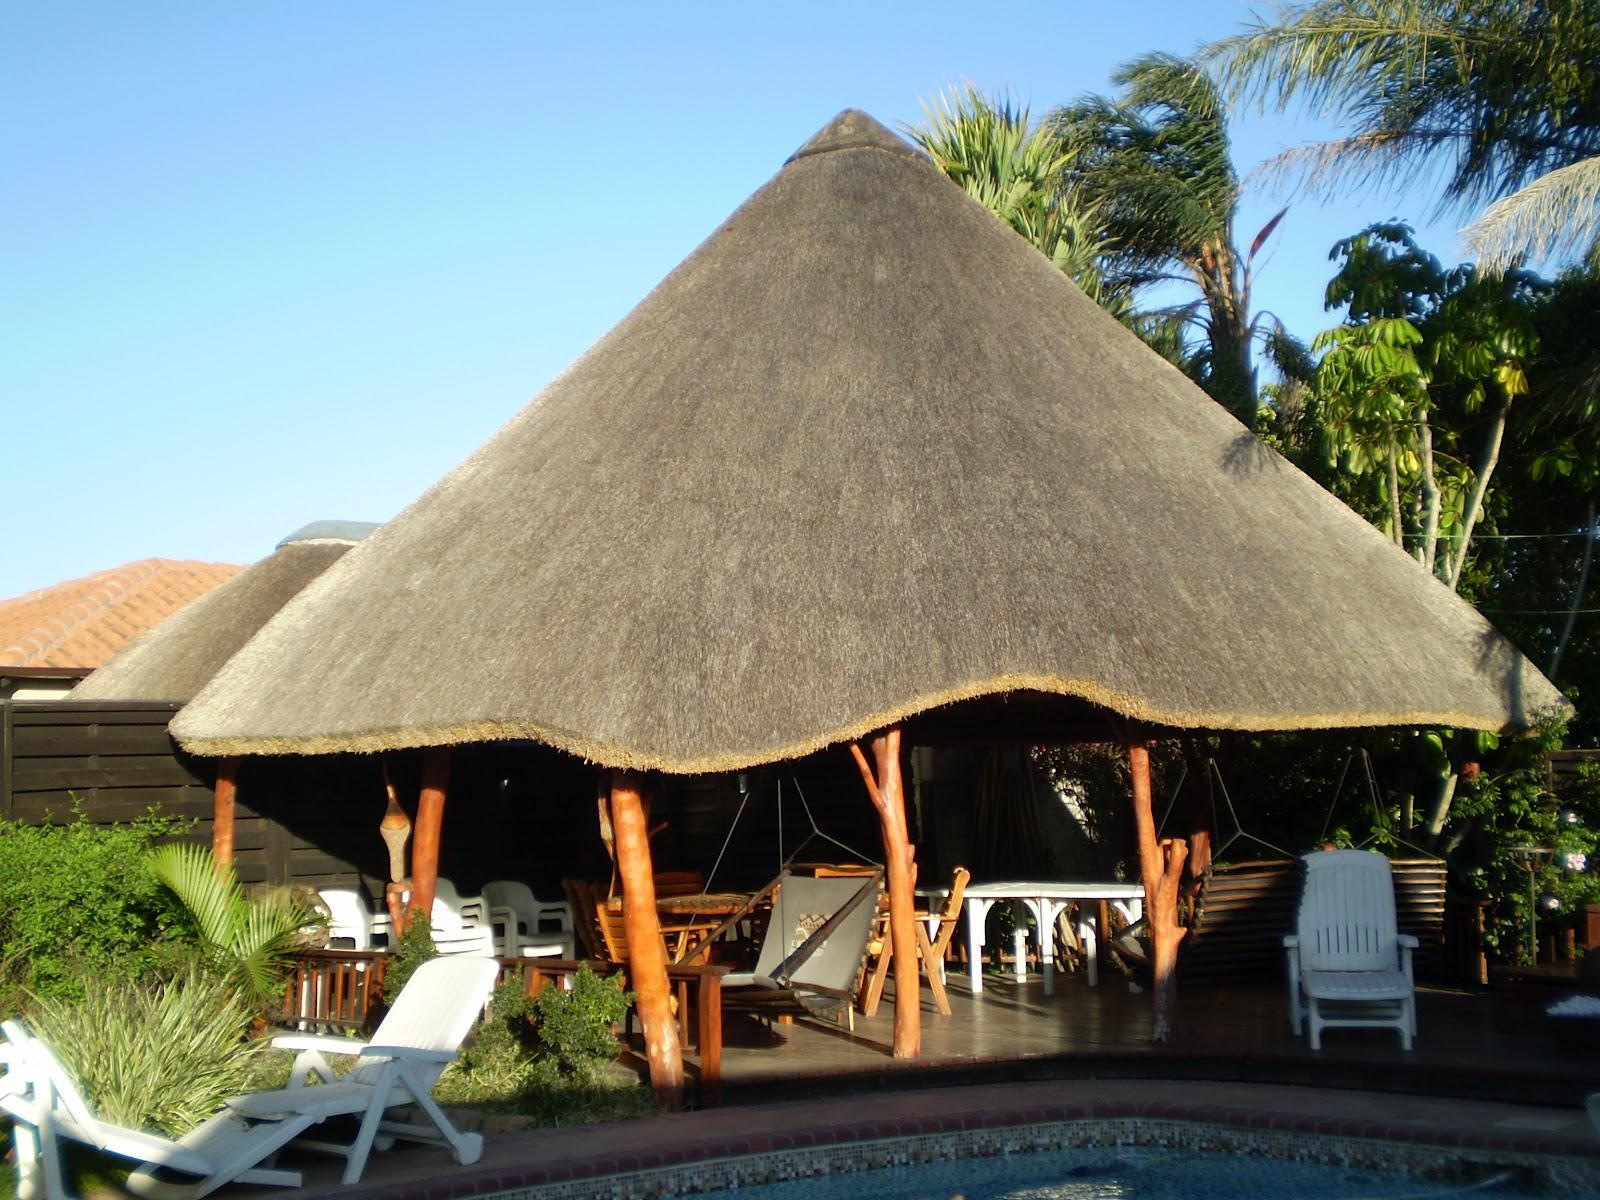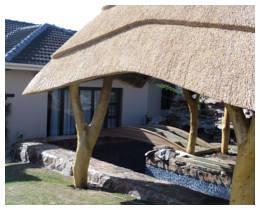The first image is the image on the left, the second image is the image on the right. Assess this claim about the two images: "The right image shows a roof made of plant material draped over leafless tree supports with forked limbs.". Correct or not? Answer yes or no. Yes. The first image is the image on the left, the second image is the image on the right. Evaluate the accuracy of this statement regarding the images: "The vertical posts are real tree trunks.". Is it true? Answer yes or no. Yes. 